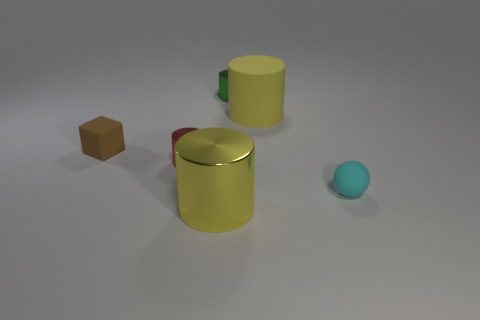How does the lighting in the scene affect the appearance of the materials of the objects? The lighting in the scene casts soft shadows and highlights which help to accentuate the different material properties of the objects. The reflective red cylinder shows bright highlights and clear reflections, which is characteristic of a metallic surface. The yellow cup, due to its matte finish, reflects light more diffusely and shows muted highlights, which emphasizes its non-metallic nature. The sphere and the block also have their textures gently enhanced by the lighting, allowing the sphere to appear smooth and the block to look more solid. 